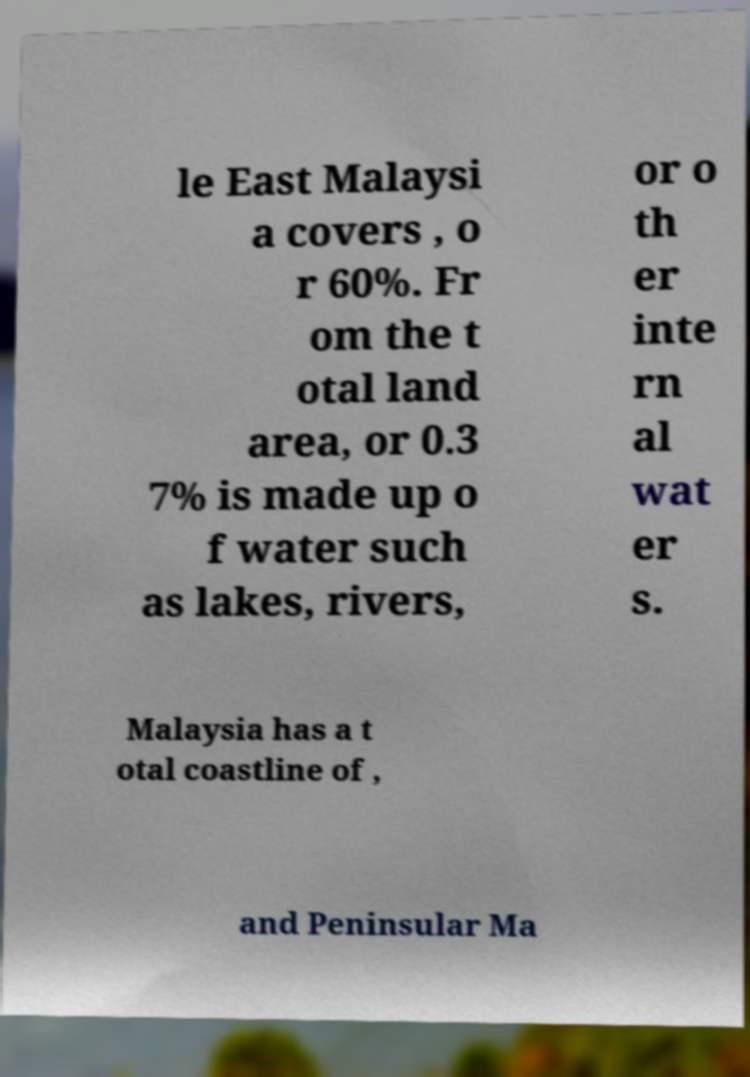For documentation purposes, I need the text within this image transcribed. Could you provide that? le East Malaysi a covers , o r 60%. Fr om the t otal land area, or 0.3 7% is made up o f water such as lakes, rivers, or o th er inte rn al wat er s. Malaysia has a t otal coastline of , and Peninsular Ma 